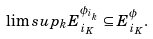<formula> <loc_0><loc_0><loc_500><loc_500>\lim s u p _ { k } E _ { i _ { K } } ^ { \phi _ { i _ { k } } } \subseteq E _ { i _ { K } } ^ { \phi } .</formula> 